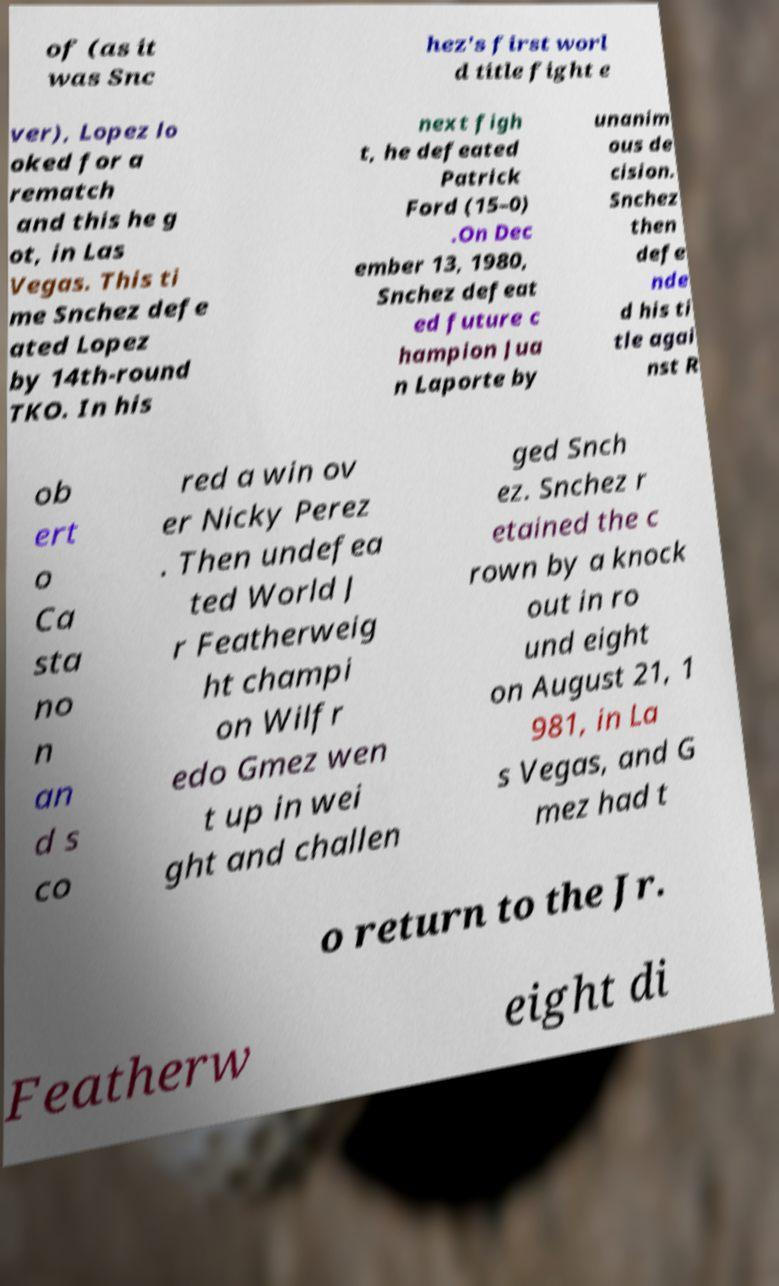What messages or text are displayed in this image? I need them in a readable, typed format. of (as it was Snc hez's first worl d title fight e ver), Lopez lo oked for a rematch and this he g ot, in Las Vegas. This ti me Snchez defe ated Lopez by 14th-round TKO. In his next figh t, he defeated Patrick Ford (15–0) .On Dec ember 13, 1980, Snchez defeat ed future c hampion Jua n Laporte by unanim ous de cision. Snchez then defe nde d his ti tle agai nst R ob ert o Ca sta no n an d s co red a win ov er Nicky Perez . Then undefea ted World J r Featherweig ht champi on Wilfr edo Gmez wen t up in wei ght and challen ged Snch ez. Snchez r etained the c rown by a knock out in ro und eight on August 21, 1 981, in La s Vegas, and G mez had t o return to the Jr. Featherw eight di 